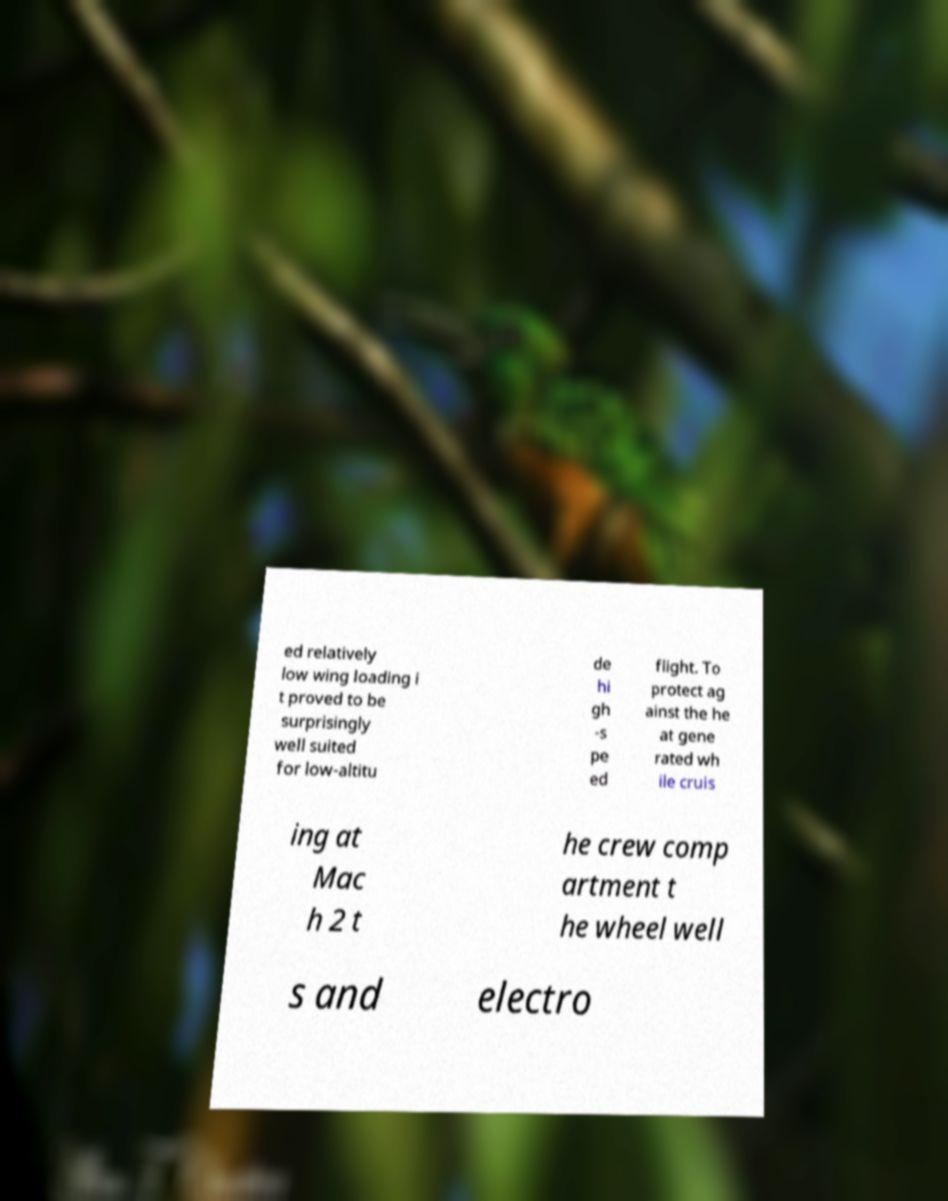Can you accurately transcribe the text from the provided image for me? ed relatively low wing loading i t proved to be surprisingly well suited for low-altitu de hi gh -s pe ed flight. To protect ag ainst the he at gene rated wh ile cruis ing at Mac h 2 t he crew comp artment t he wheel well s and electro 